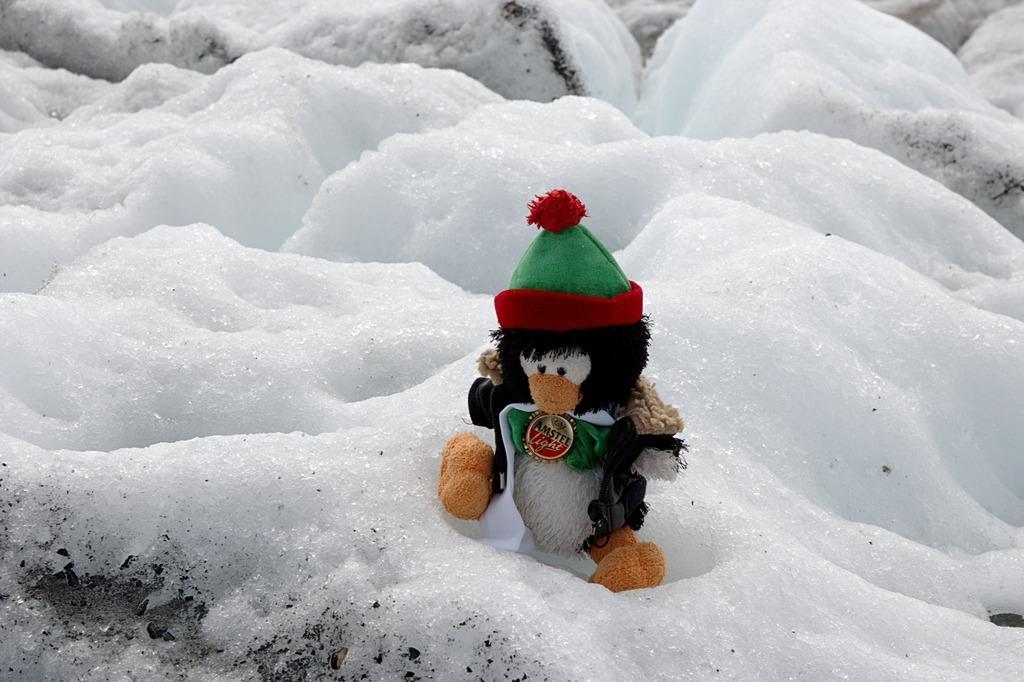Please provide a concise description of this image. In this picture we can see a monkey doll in the front, at the bottom there is snow. 